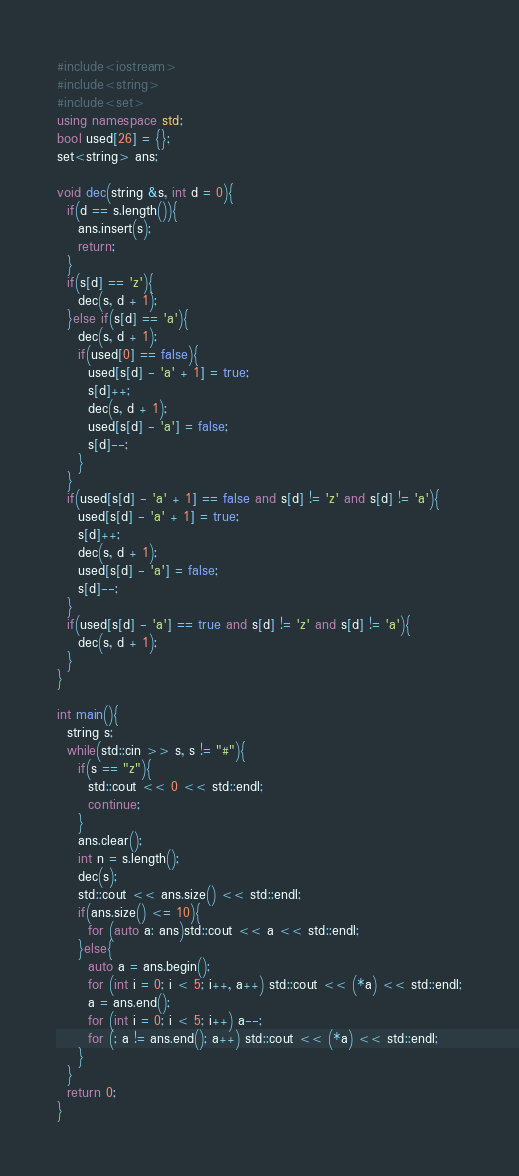Convert code to text. <code><loc_0><loc_0><loc_500><loc_500><_C++_>#include<iostream>
#include<string>
#include<set>
using namespace std;
bool used[26] = {};
set<string> ans;

void dec(string &s, int d = 0){
  if(d == s.length()){
    ans.insert(s);
    return;
  }
  if(s[d] == 'z'){
    dec(s, d + 1);
  }else if(s[d] == 'a'){
    dec(s, d + 1);
    if(used[0] == false){
      used[s[d] - 'a' + 1] = true;
      s[d]++;
      dec(s, d + 1);
      used[s[d] - 'a'] = false;
      s[d]--;
    }
  }
  if(used[s[d] - 'a' + 1] == false and s[d] != 'z' and s[d] != 'a'){
    used[s[d] - 'a' + 1] = true;
    s[d]++;
    dec(s, d + 1);
    used[s[d] - 'a'] = false;
    s[d]--;
  }
  if(used[s[d] - 'a'] == true and s[d] != 'z' and s[d] != 'a'){
    dec(s, d + 1);
  }
}

int main(){
  string s;
  while(std::cin >> s, s != "#"){
    if(s == "z"){
      std::cout << 0 << std::endl;
      continue;
    }
    ans.clear();
    int n = s.length();
    dec(s);
    std::cout << ans.size() << std::endl;
    if(ans.size() <= 10){
      for (auto a: ans)std::cout << a << std::endl;
    }else{
      auto a = ans.begin();
      for (int i = 0; i < 5; i++, a++) std::cout << (*a) << std::endl;
      a = ans.end();
      for (int i = 0; i < 5; i++) a--;
      for (; a != ans.end(); a++) std::cout << (*a) << std::endl;
    }
  }
  return 0;
}</code> 